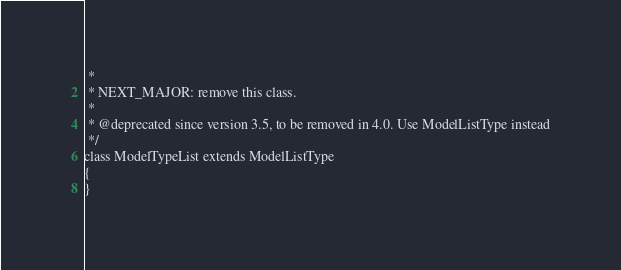<code> <loc_0><loc_0><loc_500><loc_500><_PHP_> *
 * NEXT_MAJOR: remove this class.
 *
 * @deprecated since version 3.5, to be removed in 4.0. Use ModelListType instead
 */
class ModelTypeList extends ModelListType
{
}
</code> 